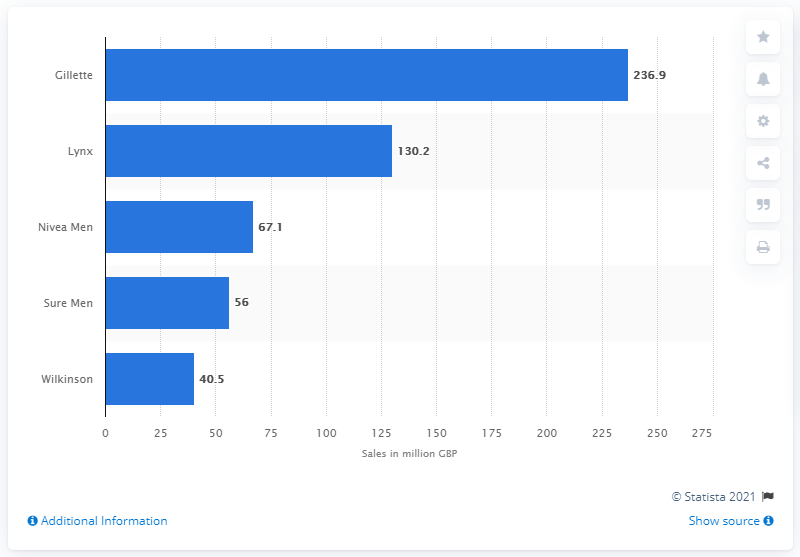Identify some key points in this picture. The brand Gillette is the number one men's toiletry product sold in the UK. Gillette's total sales in the year ending December 2014 were 236.9 billion dollars. 